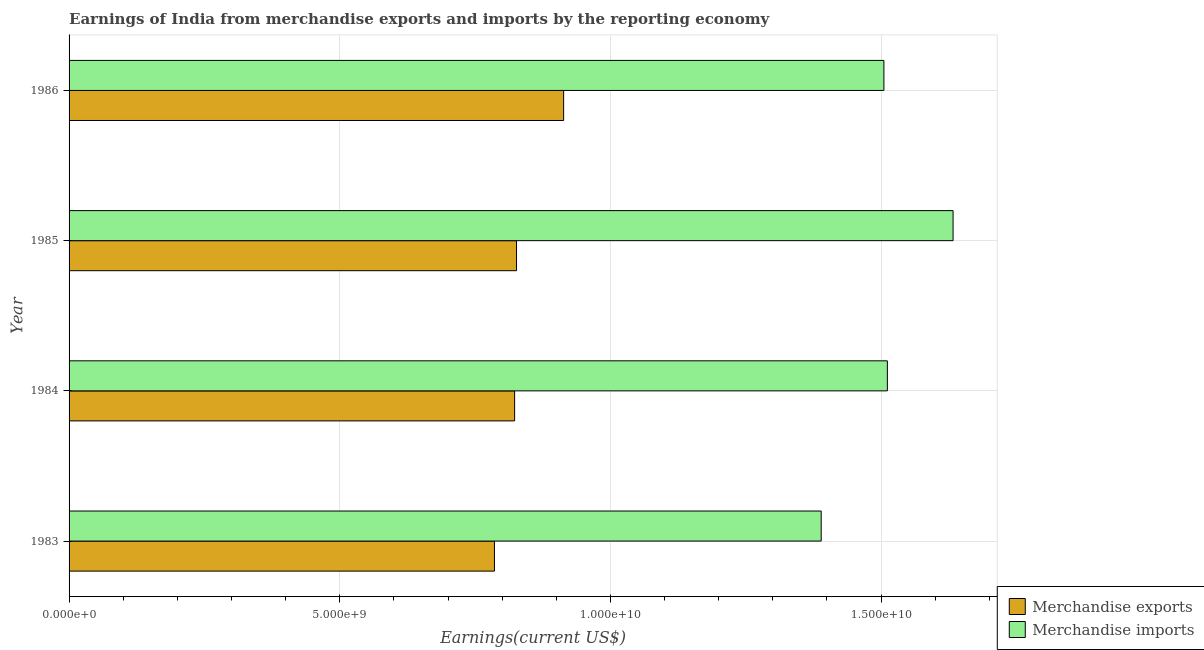How many groups of bars are there?
Keep it short and to the point. 4. How many bars are there on the 3rd tick from the top?
Keep it short and to the point. 2. How many bars are there on the 3rd tick from the bottom?
Offer a very short reply. 2. What is the label of the 1st group of bars from the top?
Offer a terse response. 1986. In how many cases, is the number of bars for a given year not equal to the number of legend labels?
Offer a terse response. 0. What is the earnings from merchandise exports in 1983?
Give a very brief answer. 7.86e+09. Across all years, what is the maximum earnings from merchandise imports?
Ensure brevity in your answer.  1.63e+1. Across all years, what is the minimum earnings from merchandise imports?
Ensure brevity in your answer.  1.39e+1. In which year was the earnings from merchandise imports maximum?
Your response must be concise. 1985. What is the total earnings from merchandise exports in the graph?
Offer a terse response. 3.35e+1. What is the difference between the earnings from merchandise exports in 1983 and that in 1986?
Provide a succinct answer. -1.28e+09. What is the difference between the earnings from merchandise exports in 1984 and the earnings from merchandise imports in 1986?
Provide a succinct answer. -6.82e+09. What is the average earnings from merchandise exports per year?
Give a very brief answer. 8.37e+09. In the year 1983, what is the difference between the earnings from merchandise imports and earnings from merchandise exports?
Make the answer very short. 6.04e+09. What is the ratio of the earnings from merchandise exports in 1983 to that in 1985?
Your response must be concise. 0.95. What is the difference between the highest and the second highest earnings from merchandise exports?
Give a very brief answer. 8.70e+08. What is the difference between the highest and the lowest earnings from merchandise exports?
Your answer should be compact. 1.28e+09. In how many years, is the earnings from merchandise imports greater than the average earnings from merchandise imports taken over all years?
Give a very brief answer. 2. Is the sum of the earnings from merchandise imports in 1985 and 1986 greater than the maximum earnings from merchandise exports across all years?
Your answer should be very brief. Yes. What does the 1st bar from the bottom in 1983 represents?
Provide a succinct answer. Merchandise exports. How many bars are there?
Offer a very short reply. 8. How many years are there in the graph?
Keep it short and to the point. 4. Are the values on the major ticks of X-axis written in scientific E-notation?
Offer a very short reply. Yes. What is the title of the graph?
Make the answer very short. Earnings of India from merchandise exports and imports by the reporting economy. Does "Net National savings" appear as one of the legend labels in the graph?
Provide a succinct answer. No. What is the label or title of the X-axis?
Provide a succinct answer. Earnings(current US$). What is the Earnings(current US$) in Merchandise exports in 1983?
Ensure brevity in your answer.  7.86e+09. What is the Earnings(current US$) in Merchandise imports in 1983?
Your response must be concise. 1.39e+1. What is the Earnings(current US$) of Merchandise exports in 1984?
Offer a terse response. 8.23e+09. What is the Earnings(current US$) of Merchandise imports in 1984?
Your answer should be very brief. 1.51e+1. What is the Earnings(current US$) of Merchandise exports in 1985?
Make the answer very short. 8.27e+09. What is the Earnings(current US$) of Merchandise imports in 1985?
Your answer should be very brief. 1.63e+1. What is the Earnings(current US$) in Merchandise exports in 1986?
Keep it short and to the point. 9.14e+09. What is the Earnings(current US$) of Merchandise imports in 1986?
Offer a terse response. 1.51e+1. Across all years, what is the maximum Earnings(current US$) in Merchandise exports?
Ensure brevity in your answer.  9.14e+09. Across all years, what is the maximum Earnings(current US$) in Merchandise imports?
Provide a short and direct response. 1.63e+1. Across all years, what is the minimum Earnings(current US$) of Merchandise exports?
Offer a very short reply. 7.86e+09. Across all years, what is the minimum Earnings(current US$) of Merchandise imports?
Your answer should be compact. 1.39e+1. What is the total Earnings(current US$) in Merchandise exports in the graph?
Keep it short and to the point. 3.35e+1. What is the total Earnings(current US$) of Merchandise imports in the graph?
Keep it short and to the point. 6.04e+1. What is the difference between the Earnings(current US$) in Merchandise exports in 1983 and that in 1984?
Keep it short and to the point. -3.73e+08. What is the difference between the Earnings(current US$) of Merchandise imports in 1983 and that in 1984?
Offer a very short reply. -1.22e+09. What is the difference between the Earnings(current US$) in Merchandise exports in 1983 and that in 1985?
Ensure brevity in your answer.  -4.08e+08. What is the difference between the Earnings(current US$) in Merchandise imports in 1983 and that in 1985?
Make the answer very short. -2.44e+09. What is the difference between the Earnings(current US$) of Merchandise exports in 1983 and that in 1986?
Your response must be concise. -1.28e+09. What is the difference between the Earnings(current US$) in Merchandise imports in 1983 and that in 1986?
Your answer should be compact. -1.16e+09. What is the difference between the Earnings(current US$) in Merchandise exports in 1984 and that in 1985?
Provide a short and direct response. -3.50e+07. What is the difference between the Earnings(current US$) in Merchandise imports in 1984 and that in 1985?
Offer a terse response. -1.21e+09. What is the difference between the Earnings(current US$) in Merchandise exports in 1984 and that in 1986?
Your answer should be compact. -9.05e+08. What is the difference between the Earnings(current US$) in Merchandise imports in 1984 and that in 1986?
Give a very brief answer. 6.38e+07. What is the difference between the Earnings(current US$) of Merchandise exports in 1985 and that in 1986?
Give a very brief answer. -8.70e+08. What is the difference between the Earnings(current US$) of Merchandise imports in 1985 and that in 1986?
Keep it short and to the point. 1.28e+09. What is the difference between the Earnings(current US$) in Merchandise exports in 1983 and the Earnings(current US$) in Merchandise imports in 1984?
Make the answer very short. -7.26e+09. What is the difference between the Earnings(current US$) of Merchandise exports in 1983 and the Earnings(current US$) of Merchandise imports in 1985?
Make the answer very short. -8.47e+09. What is the difference between the Earnings(current US$) of Merchandise exports in 1983 and the Earnings(current US$) of Merchandise imports in 1986?
Provide a succinct answer. -7.19e+09. What is the difference between the Earnings(current US$) in Merchandise exports in 1984 and the Earnings(current US$) in Merchandise imports in 1985?
Make the answer very short. -8.10e+09. What is the difference between the Earnings(current US$) in Merchandise exports in 1984 and the Earnings(current US$) in Merchandise imports in 1986?
Keep it short and to the point. -6.82e+09. What is the difference between the Earnings(current US$) in Merchandise exports in 1985 and the Earnings(current US$) in Merchandise imports in 1986?
Provide a succinct answer. -6.79e+09. What is the average Earnings(current US$) in Merchandise exports per year?
Offer a very short reply. 8.37e+09. What is the average Earnings(current US$) of Merchandise imports per year?
Keep it short and to the point. 1.51e+1. In the year 1983, what is the difference between the Earnings(current US$) in Merchandise exports and Earnings(current US$) in Merchandise imports?
Give a very brief answer. -6.04e+09. In the year 1984, what is the difference between the Earnings(current US$) of Merchandise exports and Earnings(current US$) of Merchandise imports?
Make the answer very short. -6.89e+09. In the year 1985, what is the difference between the Earnings(current US$) of Merchandise exports and Earnings(current US$) of Merchandise imports?
Keep it short and to the point. -8.06e+09. In the year 1986, what is the difference between the Earnings(current US$) in Merchandise exports and Earnings(current US$) in Merchandise imports?
Your answer should be compact. -5.92e+09. What is the ratio of the Earnings(current US$) in Merchandise exports in 1983 to that in 1984?
Your answer should be very brief. 0.95. What is the ratio of the Earnings(current US$) in Merchandise imports in 1983 to that in 1984?
Provide a short and direct response. 0.92. What is the ratio of the Earnings(current US$) of Merchandise exports in 1983 to that in 1985?
Give a very brief answer. 0.95. What is the ratio of the Earnings(current US$) of Merchandise imports in 1983 to that in 1985?
Keep it short and to the point. 0.85. What is the ratio of the Earnings(current US$) in Merchandise exports in 1983 to that in 1986?
Your response must be concise. 0.86. What is the ratio of the Earnings(current US$) in Merchandise imports in 1983 to that in 1986?
Offer a very short reply. 0.92. What is the ratio of the Earnings(current US$) of Merchandise exports in 1984 to that in 1985?
Make the answer very short. 1. What is the ratio of the Earnings(current US$) of Merchandise imports in 1984 to that in 1985?
Provide a succinct answer. 0.93. What is the ratio of the Earnings(current US$) of Merchandise exports in 1984 to that in 1986?
Offer a very short reply. 0.9. What is the ratio of the Earnings(current US$) in Merchandise exports in 1985 to that in 1986?
Keep it short and to the point. 0.9. What is the ratio of the Earnings(current US$) in Merchandise imports in 1985 to that in 1986?
Give a very brief answer. 1.08. What is the difference between the highest and the second highest Earnings(current US$) in Merchandise exports?
Your answer should be compact. 8.70e+08. What is the difference between the highest and the second highest Earnings(current US$) of Merchandise imports?
Keep it short and to the point. 1.21e+09. What is the difference between the highest and the lowest Earnings(current US$) of Merchandise exports?
Make the answer very short. 1.28e+09. What is the difference between the highest and the lowest Earnings(current US$) in Merchandise imports?
Provide a short and direct response. 2.44e+09. 